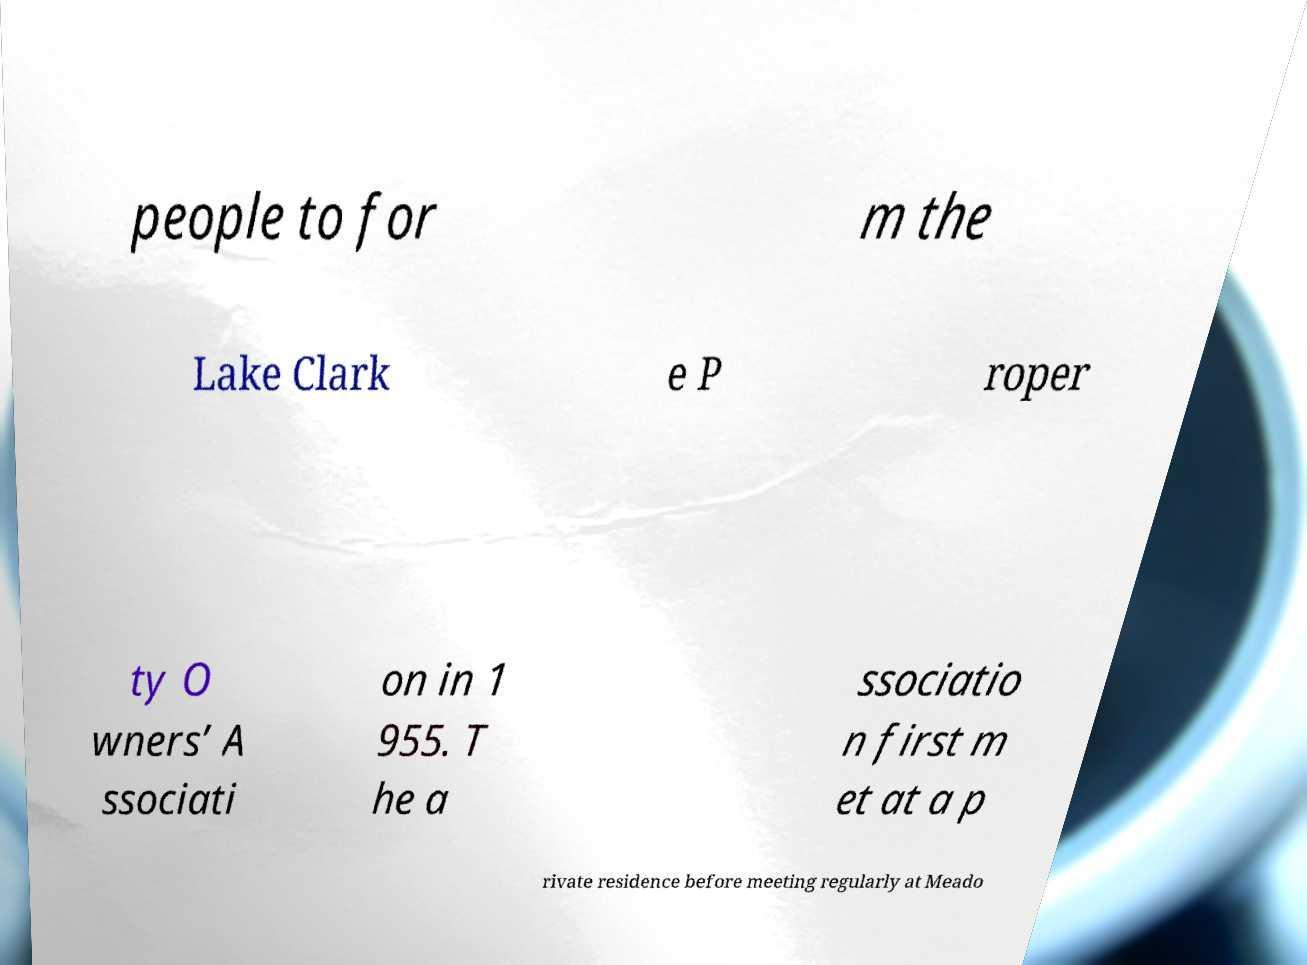What messages or text are displayed in this image? I need them in a readable, typed format. people to for m the Lake Clark e P roper ty O wners’ A ssociati on in 1 955. T he a ssociatio n first m et at a p rivate residence before meeting regularly at Meado 